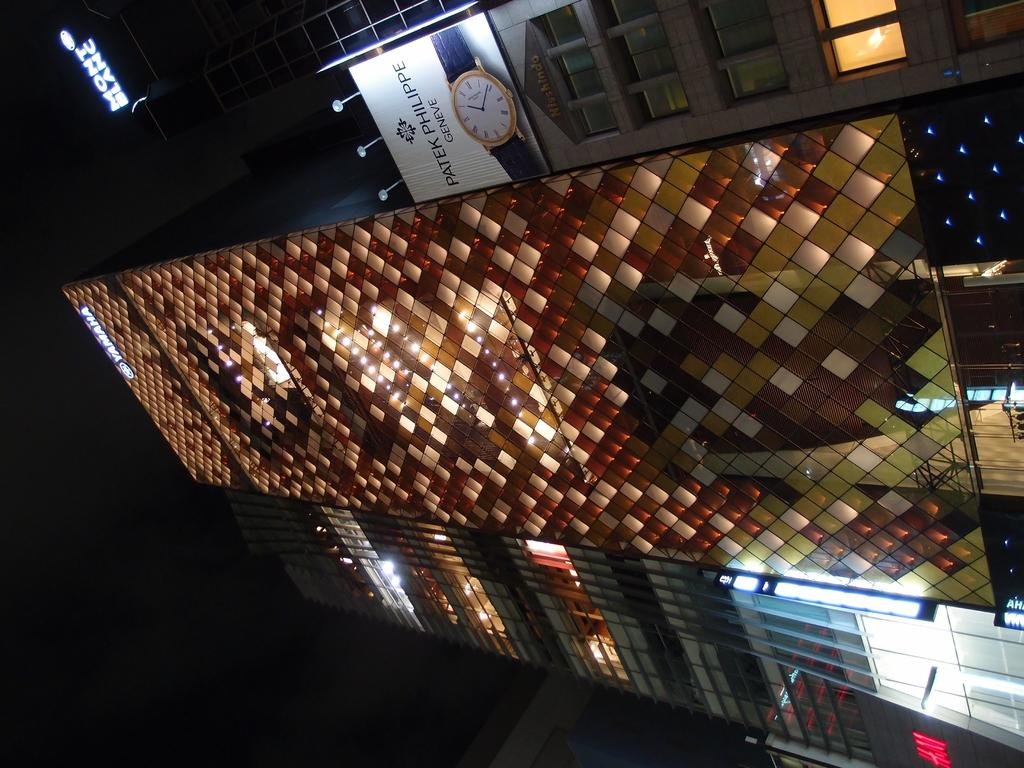What type of structures can be seen in the image? There are buildings in the image. What type of illumination is present in the image? There are electric lights in the image. What type of signage is present in the image? There is a name board in the image. What type of promotional material is present in the image? There is an advertisement in the image. What type of wheel is visible in the image? There is no wheel present in the image. What type of caption is written on the advertisement in the image? There is no caption visible on the advertisement in the image; only the image or text of the advertisement can be seen. 